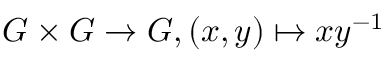<formula> <loc_0><loc_0><loc_500><loc_500>G \times G \to G , ( x , y ) \mapsto x y ^ { - 1 }</formula> 